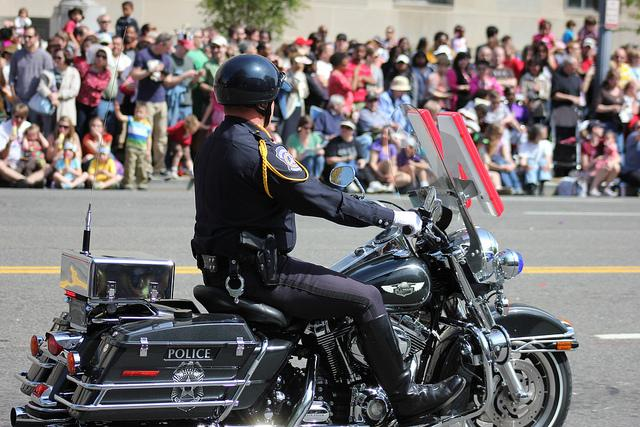What are the people on the street side focused on? parade 